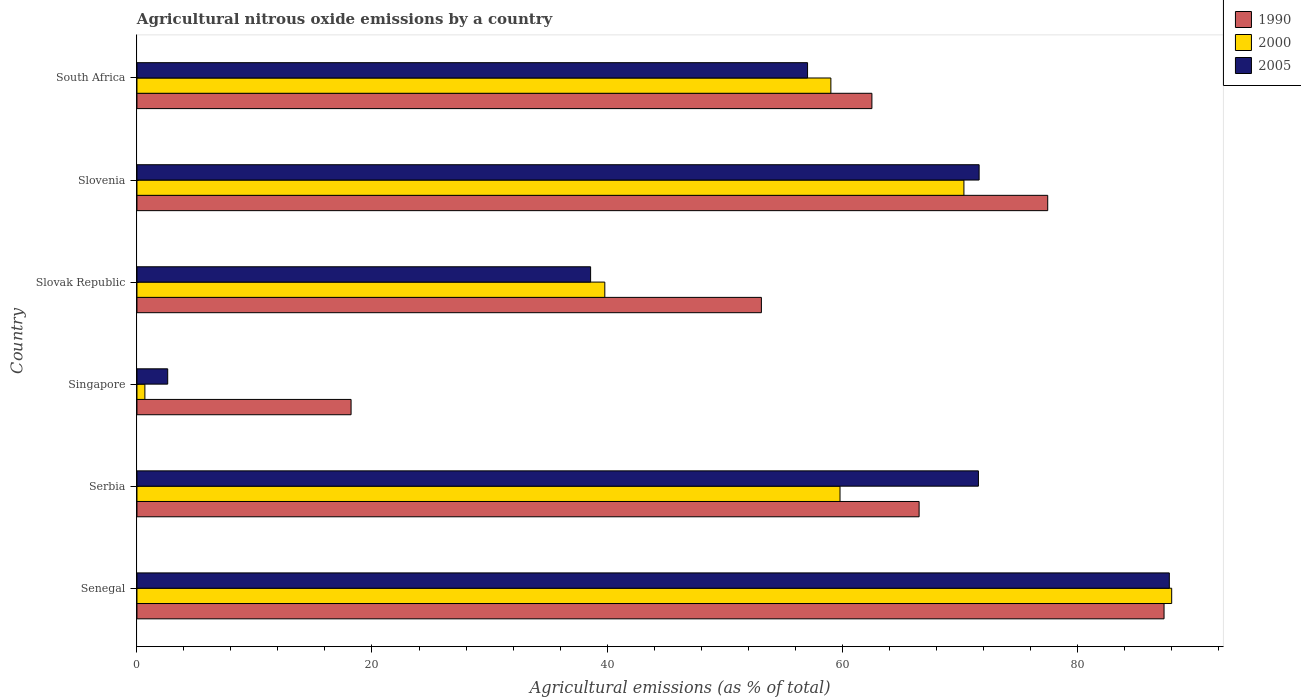How many different coloured bars are there?
Offer a very short reply. 3. How many groups of bars are there?
Keep it short and to the point. 6. Are the number of bars on each tick of the Y-axis equal?
Provide a succinct answer. Yes. How many bars are there on the 3rd tick from the bottom?
Offer a terse response. 3. What is the label of the 1st group of bars from the top?
Your response must be concise. South Africa. In how many cases, is the number of bars for a given country not equal to the number of legend labels?
Offer a terse response. 0. What is the amount of agricultural nitrous oxide emitted in 1990 in South Africa?
Offer a very short reply. 62.54. Across all countries, what is the maximum amount of agricultural nitrous oxide emitted in 2000?
Your answer should be very brief. 88.05. Across all countries, what is the minimum amount of agricultural nitrous oxide emitted in 2000?
Offer a terse response. 0.67. In which country was the amount of agricultural nitrous oxide emitted in 1990 maximum?
Provide a succinct answer. Senegal. In which country was the amount of agricultural nitrous oxide emitted in 2000 minimum?
Keep it short and to the point. Singapore. What is the total amount of agricultural nitrous oxide emitted in 1990 in the graph?
Your response must be concise. 365.36. What is the difference between the amount of agricultural nitrous oxide emitted in 1990 in Senegal and that in Serbia?
Make the answer very short. 20.84. What is the difference between the amount of agricultural nitrous oxide emitted in 2005 in Singapore and the amount of agricultural nitrous oxide emitted in 2000 in Senegal?
Your answer should be compact. -85.44. What is the average amount of agricultural nitrous oxide emitted in 1990 per country?
Make the answer very short. 60.89. What is the difference between the amount of agricultural nitrous oxide emitted in 2000 and amount of agricultural nitrous oxide emitted in 1990 in Slovenia?
Provide a succinct answer. -7.13. In how many countries, is the amount of agricultural nitrous oxide emitted in 2005 greater than 52 %?
Make the answer very short. 4. What is the ratio of the amount of agricultural nitrous oxide emitted in 2000 in Slovak Republic to that in South Africa?
Your answer should be compact. 0.67. Is the difference between the amount of agricultural nitrous oxide emitted in 2000 in Senegal and Singapore greater than the difference between the amount of agricultural nitrous oxide emitted in 1990 in Senegal and Singapore?
Provide a short and direct response. Yes. What is the difference between the highest and the second highest amount of agricultural nitrous oxide emitted in 2005?
Your answer should be very brief. 16.19. What is the difference between the highest and the lowest amount of agricultural nitrous oxide emitted in 1990?
Offer a terse response. 69.18. What does the 1st bar from the top in Serbia represents?
Make the answer very short. 2005. What does the 3rd bar from the bottom in Singapore represents?
Offer a terse response. 2005. How many bars are there?
Your answer should be very brief. 18. Are all the bars in the graph horizontal?
Provide a short and direct response. Yes. What is the difference between two consecutive major ticks on the X-axis?
Keep it short and to the point. 20. Where does the legend appear in the graph?
Give a very brief answer. Top right. What is the title of the graph?
Offer a terse response. Agricultural nitrous oxide emissions by a country. Does "1962" appear as one of the legend labels in the graph?
Your answer should be compact. No. What is the label or title of the X-axis?
Your answer should be compact. Agricultural emissions (as % of total). What is the Agricultural emissions (as % of total) in 1990 in Senegal?
Give a very brief answer. 87.4. What is the Agricultural emissions (as % of total) in 2000 in Senegal?
Provide a succinct answer. 88.05. What is the Agricultural emissions (as % of total) of 2005 in Senegal?
Offer a very short reply. 87.85. What is the Agricultural emissions (as % of total) in 1990 in Serbia?
Your response must be concise. 66.56. What is the Agricultural emissions (as % of total) of 2000 in Serbia?
Your answer should be compact. 59.83. What is the Agricultural emissions (as % of total) of 2005 in Serbia?
Offer a terse response. 71.61. What is the Agricultural emissions (as % of total) in 1990 in Singapore?
Ensure brevity in your answer.  18.22. What is the Agricultural emissions (as % of total) of 2000 in Singapore?
Your answer should be compact. 0.67. What is the Agricultural emissions (as % of total) in 2005 in Singapore?
Provide a succinct answer. 2.62. What is the Agricultural emissions (as % of total) in 1990 in Slovak Republic?
Provide a short and direct response. 53.14. What is the Agricultural emissions (as % of total) of 2000 in Slovak Republic?
Provide a succinct answer. 39.81. What is the Agricultural emissions (as % of total) of 2005 in Slovak Republic?
Offer a very short reply. 38.6. What is the Agricultural emissions (as % of total) of 1990 in Slovenia?
Offer a very short reply. 77.5. What is the Agricultural emissions (as % of total) of 2000 in Slovenia?
Your response must be concise. 70.37. What is the Agricultural emissions (as % of total) of 2005 in Slovenia?
Give a very brief answer. 71.67. What is the Agricultural emissions (as % of total) of 1990 in South Africa?
Your answer should be compact. 62.54. What is the Agricultural emissions (as % of total) of 2000 in South Africa?
Ensure brevity in your answer.  59.05. What is the Agricultural emissions (as % of total) of 2005 in South Africa?
Offer a terse response. 57.07. Across all countries, what is the maximum Agricultural emissions (as % of total) in 1990?
Your answer should be very brief. 87.4. Across all countries, what is the maximum Agricultural emissions (as % of total) in 2000?
Your answer should be very brief. 88.05. Across all countries, what is the maximum Agricultural emissions (as % of total) of 2005?
Keep it short and to the point. 87.85. Across all countries, what is the minimum Agricultural emissions (as % of total) in 1990?
Make the answer very short. 18.22. Across all countries, what is the minimum Agricultural emissions (as % of total) in 2000?
Keep it short and to the point. 0.67. Across all countries, what is the minimum Agricultural emissions (as % of total) of 2005?
Offer a terse response. 2.62. What is the total Agricultural emissions (as % of total) in 1990 in the graph?
Offer a very short reply. 365.36. What is the total Agricultural emissions (as % of total) in 2000 in the graph?
Offer a terse response. 317.79. What is the total Agricultural emissions (as % of total) in 2005 in the graph?
Offer a very short reply. 329.41. What is the difference between the Agricultural emissions (as % of total) in 1990 in Senegal and that in Serbia?
Your answer should be compact. 20.84. What is the difference between the Agricultural emissions (as % of total) in 2000 in Senegal and that in Serbia?
Offer a terse response. 28.22. What is the difference between the Agricultural emissions (as % of total) of 2005 in Senegal and that in Serbia?
Provide a short and direct response. 16.25. What is the difference between the Agricultural emissions (as % of total) in 1990 in Senegal and that in Singapore?
Provide a short and direct response. 69.18. What is the difference between the Agricultural emissions (as % of total) of 2000 in Senegal and that in Singapore?
Ensure brevity in your answer.  87.38. What is the difference between the Agricultural emissions (as % of total) in 2005 in Senegal and that in Singapore?
Provide a short and direct response. 85.23. What is the difference between the Agricultural emissions (as % of total) of 1990 in Senegal and that in Slovak Republic?
Offer a terse response. 34.26. What is the difference between the Agricultural emissions (as % of total) in 2000 in Senegal and that in Slovak Republic?
Offer a terse response. 48.24. What is the difference between the Agricultural emissions (as % of total) in 2005 in Senegal and that in Slovak Republic?
Keep it short and to the point. 49.25. What is the difference between the Agricultural emissions (as % of total) of 1990 in Senegal and that in Slovenia?
Offer a very short reply. 9.9. What is the difference between the Agricultural emissions (as % of total) of 2000 in Senegal and that in Slovenia?
Provide a succinct answer. 17.68. What is the difference between the Agricultural emissions (as % of total) in 2005 in Senegal and that in Slovenia?
Ensure brevity in your answer.  16.19. What is the difference between the Agricultural emissions (as % of total) in 1990 in Senegal and that in South Africa?
Provide a succinct answer. 24.86. What is the difference between the Agricultural emissions (as % of total) of 2000 in Senegal and that in South Africa?
Offer a very short reply. 29. What is the difference between the Agricultural emissions (as % of total) in 2005 in Senegal and that in South Africa?
Your response must be concise. 30.79. What is the difference between the Agricultural emissions (as % of total) of 1990 in Serbia and that in Singapore?
Your response must be concise. 48.34. What is the difference between the Agricultural emissions (as % of total) of 2000 in Serbia and that in Singapore?
Offer a very short reply. 59.15. What is the difference between the Agricultural emissions (as % of total) in 2005 in Serbia and that in Singapore?
Keep it short and to the point. 68.99. What is the difference between the Agricultural emissions (as % of total) in 1990 in Serbia and that in Slovak Republic?
Ensure brevity in your answer.  13.42. What is the difference between the Agricultural emissions (as % of total) of 2000 in Serbia and that in Slovak Republic?
Make the answer very short. 20.01. What is the difference between the Agricultural emissions (as % of total) in 2005 in Serbia and that in Slovak Republic?
Your answer should be compact. 33. What is the difference between the Agricultural emissions (as % of total) in 1990 in Serbia and that in Slovenia?
Offer a very short reply. -10.94. What is the difference between the Agricultural emissions (as % of total) of 2000 in Serbia and that in Slovenia?
Keep it short and to the point. -10.54. What is the difference between the Agricultural emissions (as % of total) in 2005 in Serbia and that in Slovenia?
Keep it short and to the point. -0.06. What is the difference between the Agricultural emissions (as % of total) in 1990 in Serbia and that in South Africa?
Offer a very short reply. 4.02. What is the difference between the Agricultural emissions (as % of total) in 2000 in Serbia and that in South Africa?
Provide a succinct answer. 0.78. What is the difference between the Agricultural emissions (as % of total) in 2005 in Serbia and that in South Africa?
Offer a terse response. 14.54. What is the difference between the Agricultural emissions (as % of total) of 1990 in Singapore and that in Slovak Republic?
Offer a very short reply. -34.92. What is the difference between the Agricultural emissions (as % of total) in 2000 in Singapore and that in Slovak Republic?
Make the answer very short. -39.14. What is the difference between the Agricultural emissions (as % of total) of 2005 in Singapore and that in Slovak Republic?
Your response must be concise. -35.99. What is the difference between the Agricultural emissions (as % of total) of 1990 in Singapore and that in Slovenia?
Keep it short and to the point. -59.28. What is the difference between the Agricultural emissions (as % of total) of 2000 in Singapore and that in Slovenia?
Offer a terse response. -69.7. What is the difference between the Agricultural emissions (as % of total) in 2005 in Singapore and that in Slovenia?
Ensure brevity in your answer.  -69.05. What is the difference between the Agricultural emissions (as % of total) in 1990 in Singapore and that in South Africa?
Give a very brief answer. -44.32. What is the difference between the Agricultural emissions (as % of total) of 2000 in Singapore and that in South Africa?
Provide a short and direct response. -58.38. What is the difference between the Agricultural emissions (as % of total) in 2005 in Singapore and that in South Africa?
Keep it short and to the point. -54.45. What is the difference between the Agricultural emissions (as % of total) in 1990 in Slovak Republic and that in Slovenia?
Provide a succinct answer. -24.36. What is the difference between the Agricultural emissions (as % of total) in 2000 in Slovak Republic and that in Slovenia?
Your answer should be very brief. -30.56. What is the difference between the Agricultural emissions (as % of total) in 2005 in Slovak Republic and that in Slovenia?
Ensure brevity in your answer.  -33.06. What is the difference between the Agricultural emissions (as % of total) in 1990 in Slovak Republic and that in South Africa?
Provide a short and direct response. -9.4. What is the difference between the Agricultural emissions (as % of total) of 2000 in Slovak Republic and that in South Africa?
Keep it short and to the point. -19.24. What is the difference between the Agricultural emissions (as % of total) of 2005 in Slovak Republic and that in South Africa?
Ensure brevity in your answer.  -18.46. What is the difference between the Agricultural emissions (as % of total) in 1990 in Slovenia and that in South Africa?
Offer a very short reply. 14.96. What is the difference between the Agricultural emissions (as % of total) of 2000 in Slovenia and that in South Africa?
Your answer should be very brief. 11.32. What is the difference between the Agricultural emissions (as % of total) of 2005 in Slovenia and that in South Africa?
Provide a short and direct response. 14.6. What is the difference between the Agricultural emissions (as % of total) in 1990 in Senegal and the Agricultural emissions (as % of total) in 2000 in Serbia?
Your response must be concise. 27.57. What is the difference between the Agricultural emissions (as % of total) of 1990 in Senegal and the Agricultural emissions (as % of total) of 2005 in Serbia?
Offer a terse response. 15.79. What is the difference between the Agricultural emissions (as % of total) of 2000 in Senegal and the Agricultural emissions (as % of total) of 2005 in Serbia?
Your response must be concise. 16.45. What is the difference between the Agricultural emissions (as % of total) of 1990 in Senegal and the Agricultural emissions (as % of total) of 2000 in Singapore?
Your answer should be compact. 86.73. What is the difference between the Agricultural emissions (as % of total) in 1990 in Senegal and the Agricultural emissions (as % of total) in 2005 in Singapore?
Your answer should be compact. 84.78. What is the difference between the Agricultural emissions (as % of total) in 2000 in Senegal and the Agricultural emissions (as % of total) in 2005 in Singapore?
Your answer should be compact. 85.44. What is the difference between the Agricultural emissions (as % of total) in 1990 in Senegal and the Agricultural emissions (as % of total) in 2000 in Slovak Republic?
Ensure brevity in your answer.  47.59. What is the difference between the Agricultural emissions (as % of total) of 1990 in Senegal and the Agricultural emissions (as % of total) of 2005 in Slovak Republic?
Your answer should be compact. 48.8. What is the difference between the Agricultural emissions (as % of total) in 2000 in Senegal and the Agricultural emissions (as % of total) in 2005 in Slovak Republic?
Your answer should be compact. 49.45. What is the difference between the Agricultural emissions (as % of total) of 1990 in Senegal and the Agricultural emissions (as % of total) of 2000 in Slovenia?
Offer a very short reply. 17.03. What is the difference between the Agricultural emissions (as % of total) in 1990 in Senegal and the Agricultural emissions (as % of total) in 2005 in Slovenia?
Ensure brevity in your answer.  15.74. What is the difference between the Agricultural emissions (as % of total) in 2000 in Senegal and the Agricultural emissions (as % of total) in 2005 in Slovenia?
Keep it short and to the point. 16.39. What is the difference between the Agricultural emissions (as % of total) in 1990 in Senegal and the Agricultural emissions (as % of total) in 2000 in South Africa?
Give a very brief answer. 28.35. What is the difference between the Agricultural emissions (as % of total) in 1990 in Senegal and the Agricultural emissions (as % of total) in 2005 in South Africa?
Make the answer very short. 30.34. What is the difference between the Agricultural emissions (as % of total) of 2000 in Senegal and the Agricultural emissions (as % of total) of 2005 in South Africa?
Your response must be concise. 30.99. What is the difference between the Agricultural emissions (as % of total) in 1990 in Serbia and the Agricultural emissions (as % of total) in 2000 in Singapore?
Provide a short and direct response. 65.88. What is the difference between the Agricultural emissions (as % of total) of 1990 in Serbia and the Agricultural emissions (as % of total) of 2005 in Singapore?
Your answer should be compact. 63.94. What is the difference between the Agricultural emissions (as % of total) of 2000 in Serbia and the Agricultural emissions (as % of total) of 2005 in Singapore?
Give a very brief answer. 57.21. What is the difference between the Agricultural emissions (as % of total) in 1990 in Serbia and the Agricultural emissions (as % of total) in 2000 in Slovak Republic?
Offer a terse response. 26.75. What is the difference between the Agricultural emissions (as % of total) of 1990 in Serbia and the Agricultural emissions (as % of total) of 2005 in Slovak Republic?
Give a very brief answer. 27.96. What is the difference between the Agricultural emissions (as % of total) in 2000 in Serbia and the Agricultural emissions (as % of total) in 2005 in Slovak Republic?
Provide a short and direct response. 21.22. What is the difference between the Agricultural emissions (as % of total) in 1990 in Serbia and the Agricultural emissions (as % of total) in 2000 in Slovenia?
Your response must be concise. -3.81. What is the difference between the Agricultural emissions (as % of total) in 1990 in Serbia and the Agricultural emissions (as % of total) in 2005 in Slovenia?
Provide a short and direct response. -5.11. What is the difference between the Agricultural emissions (as % of total) of 2000 in Serbia and the Agricultural emissions (as % of total) of 2005 in Slovenia?
Keep it short and to the point. -11.84. What is the difference between the Agricultural emissions (as % of total) in 1990 in Serbia and the Agricultural emissions (as % of total) in 2000 in South Africa?
Offer a terse response. 7.51. What is the difference between the Agricultural emissions (as % of total) in 1990 in Serbia and the Agricultural emissions (as % of total) in 2005 in South Africa?
Provide a short and direct response. 9.49. What is the difference between the Agricultural emissions (as % of total) in 2000 in Serbia and the Agricultural emissions (as % of total) in 2005 in South Africa?
Offer a very short reply. 2.76. What is the difference between the Agricultural emissions (as % of total) in 1990 in Singapore and the Agricultural emissions (as % of total) in 2000 in Slovak Republic?
Make the answer very short. -21.59. What is the difference between the Agricultural emissions (as % of total) in 1990 in Singapore and the Agricultural emissions (as % of total) in 2005 in Slovak Republic?
Make the answer very short. -20.38. What is the difference between the Agricultural emissions (as % of total) of 2000 in Singapore and the Agricultural emissions (as % of total) of 2005 in Slovak Republic?
Ensure brevity in your answer.  -37.93. What is the difference between the Agricultural emissions (as % of total) in 1990 in Singapore and the Agricultural emissions (as % of total) in 2000 in Slovenia?
Give a very brief answer. -52.15. What is the difference between the Agricultural emissions (as % of total) of 1990 in Singapore and the Agricultural emissions (as % of total) of 2005 in Slovenia?
Ensure brevity in your answer.  -53.44. What is the difference between the Agricultural emissions (as % of total) of 2000 in Singapore and the Agricultural emissions (as % of total) of 2005 in Slovenia?
Offer a very short reply. -70.99. What is the difference between the Agricultural emissions (as % of total) in 1990 in Singapore and the Agricultural emissions (as % of total) in 2000 in South Africa?
Make the answer very short. -40.83. What is the difference between the Agricultural emissions (as % of total) in 1990 in Singapore and the Agricultural emissions (as % of total) in 2005 in South Africa?
Your answer should be compact. -38.85. What is the difference between the Agricultural emissions (as % of total) in 2000 in Singapore and the Agricultural emissions (as % of total) in 2005 in South Africa?
Offer a very short reply. -56.39. What is the difference between the Agricultural emissions (as % of total) in 1990 in Slovak Republic and the Agricultural emissions (as % of total) in 2000 in Slovenia?
Give a very brief answer. -17.23. What is the difference between the Agricultural emissions (as % of total) in 1990 in Slovak Republic and the Agricultural emissions (as % of total) in 2005 in Slovenia?
Your answer should be compact. -18.53. What is the difference between the Agricultural emissions (as % of total) in 2000 in Slovak Republic and the Agricultural emissions (as % of total) in 2005 in Slovenia?
Make the answer very short. -31.85. What is the difference between the Agricultural emissions (as % of total) of 1990 in Slovak Republic and the Agricultural emissions (as % of total) of 2000 in South Africa?
Make the answer very short. -5.91. What is the difference between the Agricultural emissions (as % of total) in 1990 in Slovak Republic and the Agricultural emissions (as % of total) in 2005 in South Africa?
Your response must be concise. -3.93. What is the difference between the Agricultural emissions (as % of total) in 2000 in Slovak Republic and the Agricultural emissions (as % of total) in 2005 in South Africa?
Your answer should be compact. -17.25. What is the difference between the Agricultural emissions (as % of total) in 1990 in Slovenia and the Agricultural emissions (as % of total) in 2000 in South Africa?
Your response must be concise. 18.45. What is the difference between the Agricultural emissions (as % of total) of 1990 in Slovenia and the Agricultural emissions (as % of total) of 2005 in South Africa?
Ensure brevity in your answer.  20.44. What is the difference between the Agricultural emissions (as % of total) in 2000 in Slovenia and the Agricultural emissions (as % of total) in 2005 in South Africa?
Keep it short and to the point. 13.31. What is the average Agricultural emissions (as % of total) in 1990 per country?
Offer a very short reply. 60.89. What is the average Agricultural emissions (as % of total) of 2000 per country?
Your answer should be very brief. 52.96. What is the average Agricultural emissions (as % of total) of 2005 per country?
Your response must be concise. 54.9. What is the difference between the Agricultural emissions (as % of total) of 1990 and Agricultural emissions (as % of total) of 2000 in Senegal?
Offer a terse response. -0.65. What is the difference between the Agricultural emissions (as % of total) in 1990 and Agricultural emissions (as % of total) in 2005 in Senegal?
Give a very brief answer. -0.45. What is the difference between the Agricultural emissions (as % of total) in 2000 and Agricultural emissions (as % of total) in 2005 in Senegal?
Offer a very short reply. 0.2. What is the difference between the Agricultural emissions (as % of total) in 1990 and Agricultural emissions (as % of total) in 2000 in Serbia?
Your answer should be compact. 6.73. What is the difference between the Agricultural emissions (as % of total) in 1990 and Agricultural emissions (as % of total) in 2005 in Serbia?
Offer a terse response. -5.05. What is the difference between the Agricultural emissions (as % of total) of 2000 and Agricultural emissions (as % of total) of 2005 in Serbia?
Provide a succinct answer. -11.78. What is the difference between the Agricultural emissions (as % of total) of 1990 and Agricultural emissions (as % of total) of 2000 in Singapore?
Offer a very short reply. 17.55. What is the difference between the Agricultural emissions (as % of total) of 1990 and Agricultural emissions (as % of total) of 2005 in Singapore?
Provide a succinct answer. 15.6. What is the difference between the Agricultural emissions (as % of total) of 2000 and Agricultural emissions (as % of total) of 2005 in Singapore?
Your answer should be very brief. -1.94. What is the difference between the Agricultural emissions (as % of total) of 1990 and Agricultural emissions (as % of total) of 2000 in Slovak Republic?
Your answer should be very brief. 13.32. What is the difference between the Agricultural emissions (as % of total) in 1990 and Agricultural emissions (as % of total) in 2005 in Slovak Republic?
Ensure brevity in your answer.  14.53. What is the difference between the Agricultural emissions (as % of total) of 2000 and Agricultural emissions (as % of total) of 2005 in Slovak Republic?
Give a very brief answer. 1.21. What is the difference between the Agricultural emissions (as % of total) of 1990 and Agricultural emissions (as % of total) of 2000 in Slovenia?
Keep it short and to the point. 7.13. What is the difference between the Agricultural emissions (as % of total) of 1990 and Agricultural emissions (as % of total) of 2005 in Slovenia?
Your answer should be compact. 5.84. What is the difference between the Agricultural emissions (as % of total) in 2000 and Agricultural emissions (as % of total) in 2005 in Slovenia?
Your answer should be very brief. -1.29. What is the difference between the Agricultural emissions (as % of total) of 1990 and Agricultural emissions (as % of total) of 2000 in South Africa?
Provide a short and direct response. 3.49. What is the difference between the Agricultural emissions (as % of total) of 1990 and Agricultural emissions (as % of total) of 2005 in South Africa?
Your answer should be very brief. 5.48. What is the difference between the Agricultural emissions (as % of total) in 2000 and Agricultural emissions (as % of total) in 2005 in South Africa?
Your response must be concise. 1.98. What is the ratio of the Agricultural emissions (as % of total) of 1990 in Senegal to that in Serbia?
Provide a short and direct response. 1.31. What is the ratio of the Agricultural emissions (as % of total) in 2000 in Senegal to that in Serbia?
Your response must be concise. 1.47. What is the ratio of the Agricultural emissions (as % of total) of 2005 in Senegal to that in Serbia?
Your answer should be very brief. 1.23. What is the ratio of the Agricultural emissions (as % of total) of 1990 in Senegal to that in Singapore?
Give a very brief answer. 4.8. What is the ratio of the Agricultural emissions (as % of total) of 2000 in Senegal to that in Singapore?
Keep it short and to the point. 130.59. What is the ratio of the Agricultural emissions (as % of total) of 2005 in Senegal to that in Singapore?
Ensure brevity in your answer.  33.58. What is the ratio of the Agricultural emissions (as % of total) in 1990 in Senegal to that in Slovak Republic?
Give a very brief answer. 1.64. What is the ratio of the Agricultural emissions (as % of total) of 2000 in Senegal to that in Slovak Republic?
Offer a very short reply. 2.21. What is the ratio of the Agricultural emissions (as % of total) of 2005 in Senegal to that in Slovak Republic?
Offer a terse response. 2.28. What is the ratio of the Agricultural emissions (as % of total) in 1990 in Senegal to that in Slovenia?
Keep it short and to the point. 1.13. What is the ratio of the Agricultural emissions (as % of total) in 2000 in Senegal to that in Slovenia?
Give a very brief answer. 1.25. What is the ratio of the Agricultural emissions (as % of total) of 2005 in Senegal to that in Slovenia?
Offer a terse response. 1.23. What is the ratio of the Agricultural emissions (as % of total) in 1990 in Senegal to that in South Africa?
Offer a very short reply. 1.4. What is the ratio of the Agricultural emissions (as % of total) of 2000 in Senegal to that in South Africa?
Provide a short and direct response. 1.49. What is the ratio of the Agricultural emissions (as % of total) of 2005 in Senegal to that in South Africa?
Ensure brevity in your answer.  1.54. What is the ratio of the Agricultural emissions (as % of total) in 1990 in Serbia to that in Singapore?
Provide a succinct answer. 3.65. What is the ratio of the Agricultural emissions (as % of total) of 2000 in Serbia to that in Singapore?
Give a very brief answer. 88.73. What is the ratio of the Agricultural emissions (as % of total) of 2005 in Serbia to that in Singapore?
Provide a short and direct response. 27.37. What is the ratio of the Agricultural emissions (as % of total) in 1990 in Serbia to that in Slovak Republic?
Give a very brief answer. 1.25. What is the ratio of the Agricultural emissions (as % of total) in 2000 in Serbia to that in Slovak Republic?
Ensure brevity in your answer.  1.5. What is the ratio of the Agricultural emissions (as % of total) in 2005 in Serbia to that in Slovak Republic?
Your response must be concise. 1.85. What is the ratio of the Agricultural emissions (as % of total) in 1990 in Serbia to that in Slovenia?
Offer a terse response. 0.86. What is the ratio of the Agricultural emissions (as % of total) of 2000 in Serbia to that in Slovenia?
Give a very brief answer. 0.85. What is the ratio of the Agricultural emissions (as % of total) of 1990 in Serbia to that in South Africa?
Ensure brevity in your answer.  1.06. What is the ratio of the Agricultural emissions (as % of total) of 2000 in Serbia to that in South Africa?
Make the answer very short. 1.01. What is the ratio of the Agricultural emissions (as % of total) in 2005 in Serbia to that in South Africa?
Make the answer very short. 1.25. What is the ratio of the Agricultural emissions (as % of total) in 1990 in Singapore to that in Slovak Republic?
Ensure brevity in your answer.  0.34. What is the ratio of the Agricultural emissions (as % of total) in 2000 in Singapore to that in Slovak Republic?
Offer a very short reply. 0.02. What is the ratio of the Agricultural emissions (as % of total) in 2005 in Singapore to that in Slovak Republic?
Make the answer very short. 0.07. What is the ratio of the Agricultural emissions (as % of total) of 1990 in Singapore to that in Slovenia?
Give a very brief answer. 0.24. What is the ratio of the Agricultural emissions (as % of total) of 2000 in Singapore to that in Slovenia?
Provide a short and direct response. 0.01. What is the ratio of the Agricultural emissions (as % of total) of 2005 in Singapore to that in Slovenia?
Give a very brief answer. 0.04. What is the ratio of the Agricultural emissions (as % of total) in 1990 in Singapore to that in South Africa?
Your response must be concise. 0.29. What is the ratio of the Agricultural emissions (as % of total) of 2000 in Singapore to that in South Africa?
Your answer should be very brief. 0.01. What is the ratio of the Agricultural emissions (as % of total) in 2005 in Singapore to that in South Africa?
Provide a short and direct response. 0.05. What is the ratio of the Agricultural emissions (as % of total) in 1990 in Slovak Republic to that in Slovenia?
Offer a very short reply. 0.69. What is the ratio of the Agricultural emissions (as % of total) of 2000 in Slovak Republic to that in Slovenia?
Provide a short and direct response. 0.57. What is the ratio of the Agricultural emissions (as % of total) of 2005 in Slovak Republic to that in Slovenia?
Provide a short and direct response. 0.54. What is the ratio of the Agricultural emissions (as % of total) of 1990 in Slovak Republic to that in South Africa?
Keep it short and to the point. 0.85. What is the ratio of the Agricultural emissions (as % of total) in 2000 in Slovak Republic to that in South Africa?
Offer a very short reply. 0.67. What is the ratio of the Agricultural emissions (as % of total) in 2005 in Slovak Republic to that in South Africa?
Ensure brevity in your answer.  0.68. What is the ratio of the Agricultural emissions (as % of total) in 1990 in Slovenia to that in South Africa?
Your answer should be very brief. 1.24. What is the ratio of the Agricultural emissions (as % of total) in 2000 in Slovenia to that in South Africa?
Provide a succinct answer. 1.19. What is the ratio of the Agricultural emissions (as % of total) of 2005 in Slovenia to that in South Africa?
Make the answer very short. 1.26. What is the difference between the highest and the second highest Agricultural emissions (as % of total) in 1990?
Ensure brevity in your answer.  9.9. What is the difference between the highest and the second highest Agricultural emissions (as % of total) in 2000?
Ensure brevity in your answer.  17.68. What is the difference between the highest and the second highest Agricultural emissions (as % of total) in 2005?
Your answer should be very brief. 16.19. What is the difference between the highest and the lowest Agricultural emissions (as % of total) of 1990?
Offer a very short reply. 69.18. What is the difference between the highest and the lowest Agricultural emissions (as % of total) in 2000?
Give a very brief answer. 87.38. What is the difference between the highest and the lowest Agricultural emissions (as % of total) of 2005?
Offer a terse response. 85.23. 